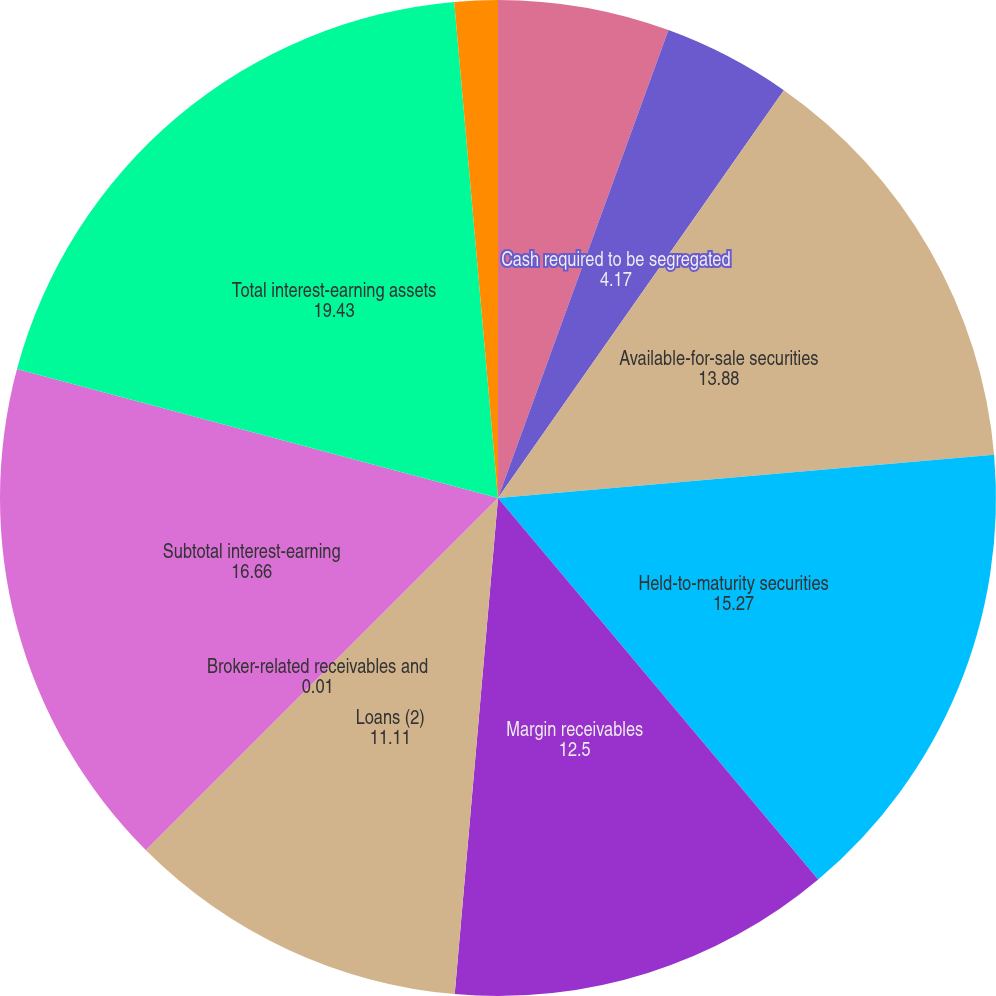Convert chart to OTSL. <chart><loc_0><loc_0><loc_500><loc_500><pie_chart><fcel>Cash and equivalents<fcel>Cash required to be segregated<fcel>Available-for-sale securities<fcel>Held-to-maturity securities<fcel>Margin receivables<fcel>Loans (2)<fcel>Broker-related receivables and<fcel>Subtotal interest-earning<fcel>Total interest-earning assets<fcel>Sweep deposits<nl><fcel>5.56%<fcel>4.17%<fcel>13.88%<fcel>15.27%<fcel>12.5%<fcel>11.11%<fcel>0.01%<fcel>16.66%<fcel>19.43%<fcel>1.4%<nl></chart> 